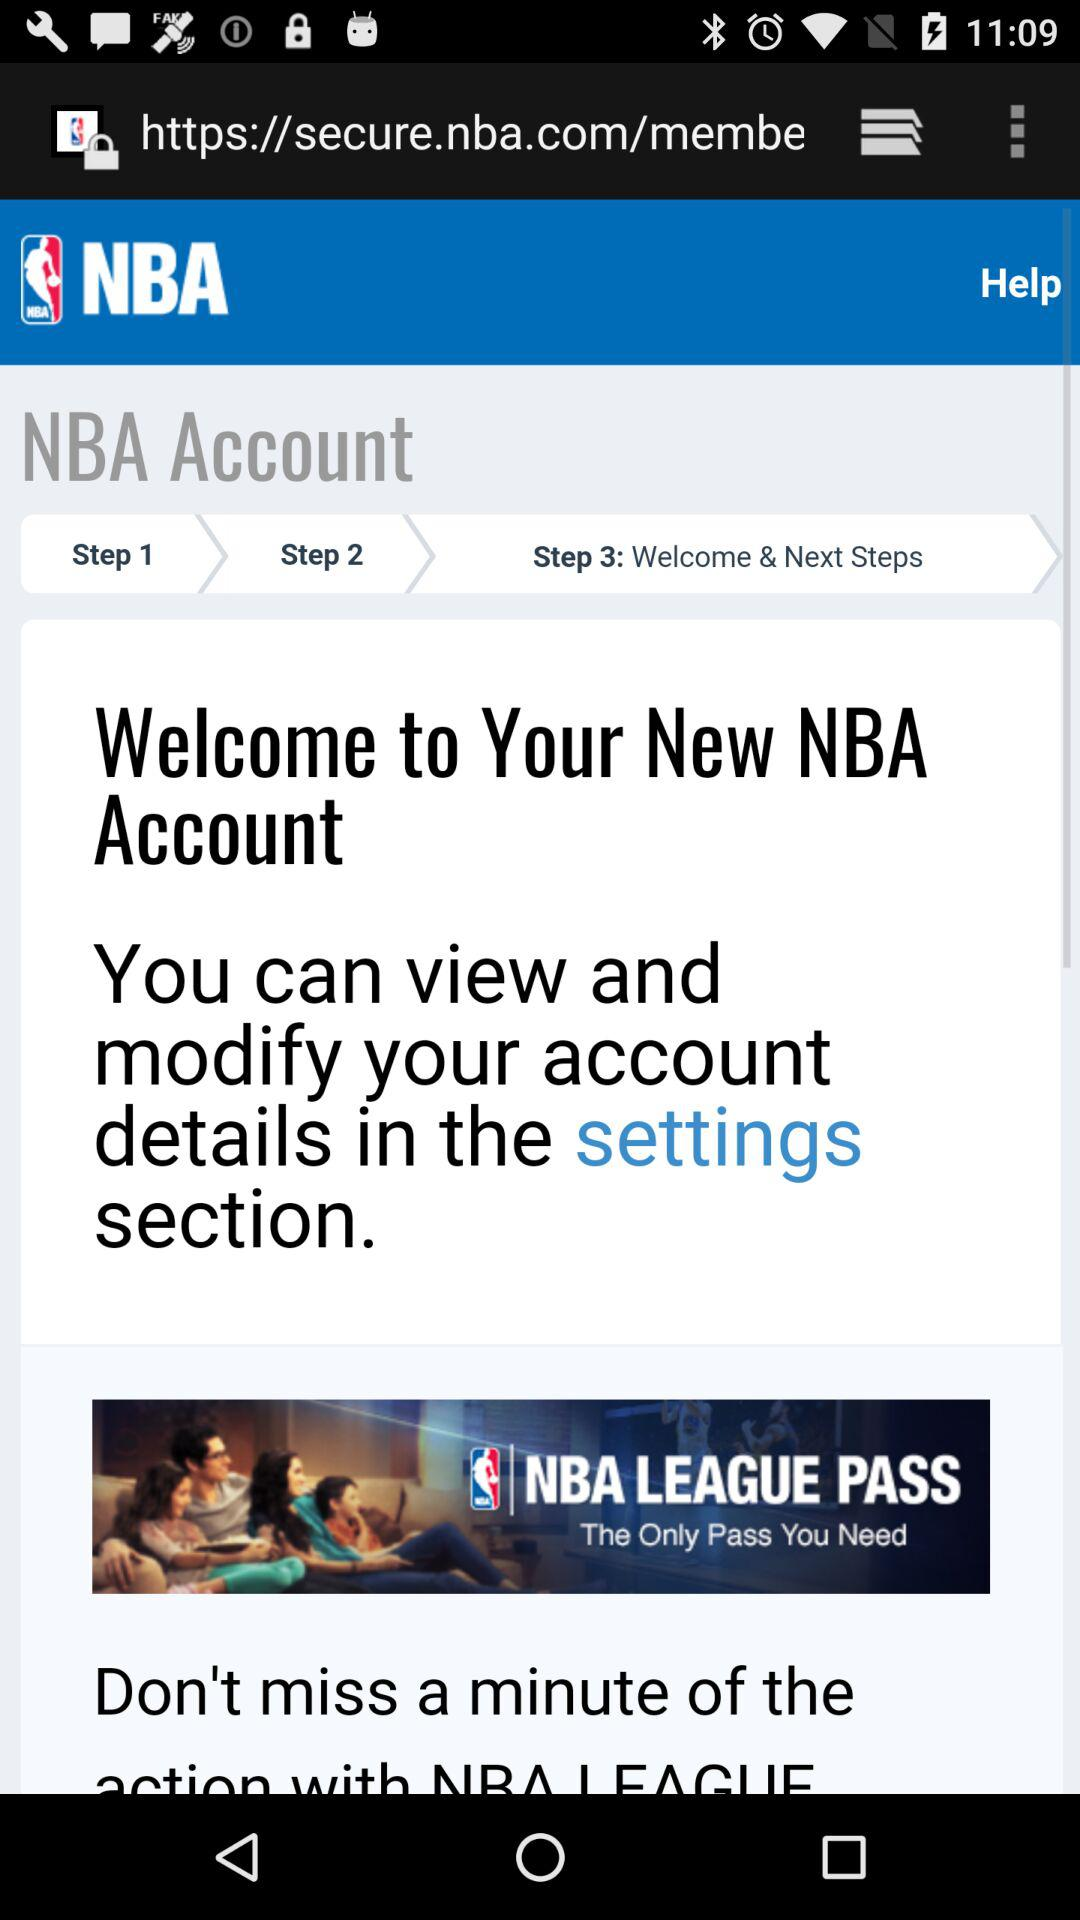Where can the account details be modified? The account details can be modified in the settings section. 